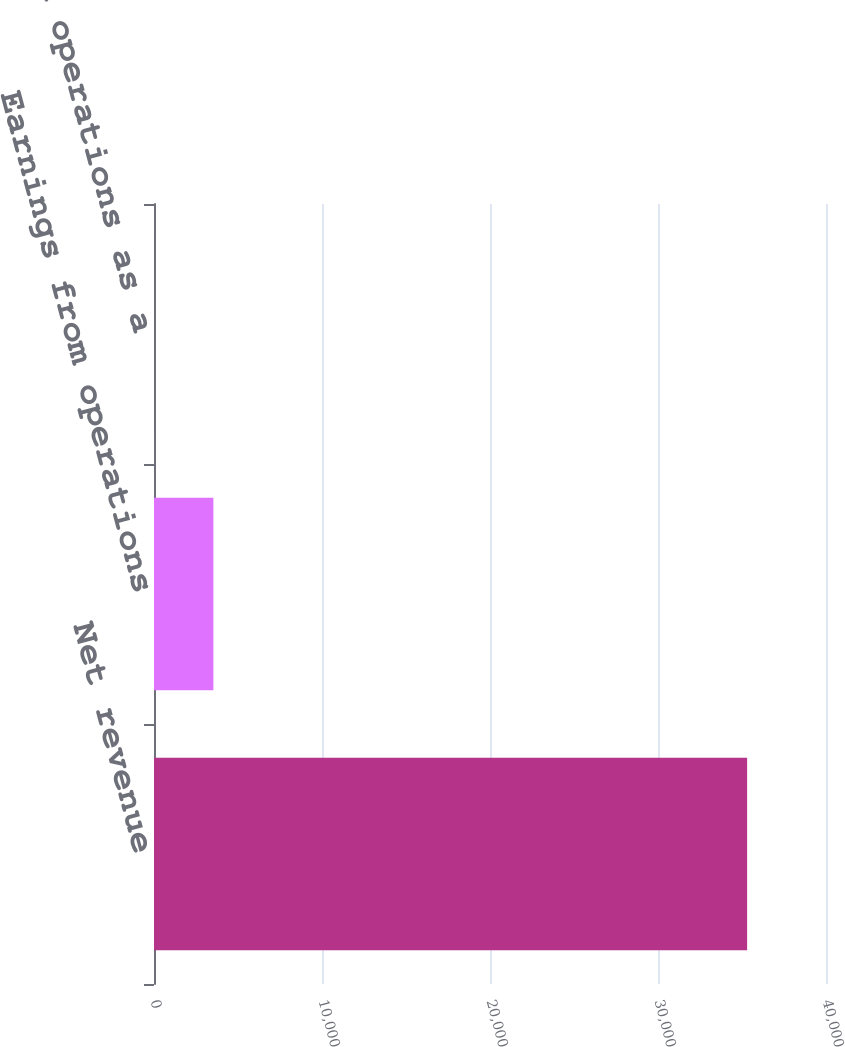<chart> <loc_0><loc_0><loc_500><loc_500><bar_chart><fcel>Net revenue<fcel>Earnings from operations<fcel>Earnings from operations as a<nl><fcel>35305<fcel>3534.73<fcel>4.7<nl></chart> 